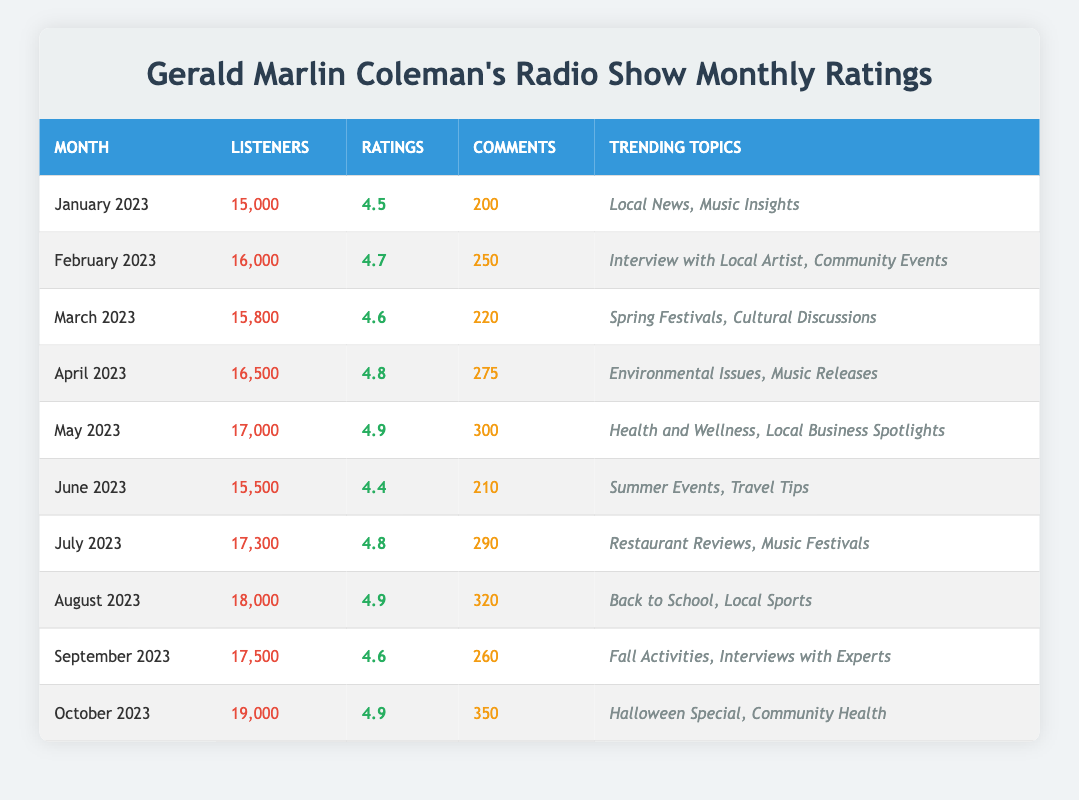What was the highest rating for the Gerald Marlin Coleman's radio show? The highest rating in the table is found by looking for the maximum value in the Ratings column. Scanning the Ratings, the highest value is 4.9, which occurs in May 2023 and also in August 2023 and October 2023.
Answer: 4.9 How many listeners did the show have in June 2023? The table provides the number of listeners for each month, and for June 2023, the number of listeners is explicitly stated as 15,500.
Answer: 15,500 Did the show receive more comments in October 2023 than in April 2023? To determine this, we can compare the Comments for both months. In October 2023, the show received 350 comments, while in April 2023, it received 275 comments. Since 350 is greater than 275, the statement is true.
Answer: Yes What is the average number of listeners over the last year? To find the average number of listeners, sum the number of listeners from all months: 15,000 + 16,000 + 15,800 + 16,500 + 17,000 + 15,500 + 17,300 + 18,000 + 17,500 + 19,000 =  173,600. Then, divide by the number of months (10): 173,600 / 10 = 17,360.
Answer: 17,360 In which month did the show have the most comments and what was the number? We must look through the Comments column to find the maximum value. The highest number of comments is 350 in October 2023, indicating this is the month with the most comments.
Answer: October 2023, 350 What is the difference in the number of listeners between August 2023 and January 2023? The number of listeners in August 2023 is 18,000 and in January 2023 it is 15,000. To find the difference: 18,000 - 15,000 = 3,000.
Answer: 3,000 Were there more listeners in July 2023 than in September 2023? In July 2023, there were 17,300 listeners, and in September 2023, there were 17,500 listeners. Comparing these two values shows that 17,300 is less than 17,500, so the answer is no.
Answer: No What trending topic was associated with the highest rating month? The highest rating of 4.9 occurs in two instances: May 2023 and October 2023. Checking the Trending Topics for both months, May's topics are "Health and Wellness, Local Business Spotlights" and October's are "Halloween Special, Community Health." Therefore, both associated periods can be cited.
Answer: May 2023: Health and Wellness, Local Business Spotlights; October 2023: Halloween Special, Community Health How many total comments were made across all months? To find the total comments, add the Comments from each month: 200 + 250 + 220 + 275 + 300 + 210 + 290 + 320 + 260 + 350 = 2,375.
Answer: 2,375 